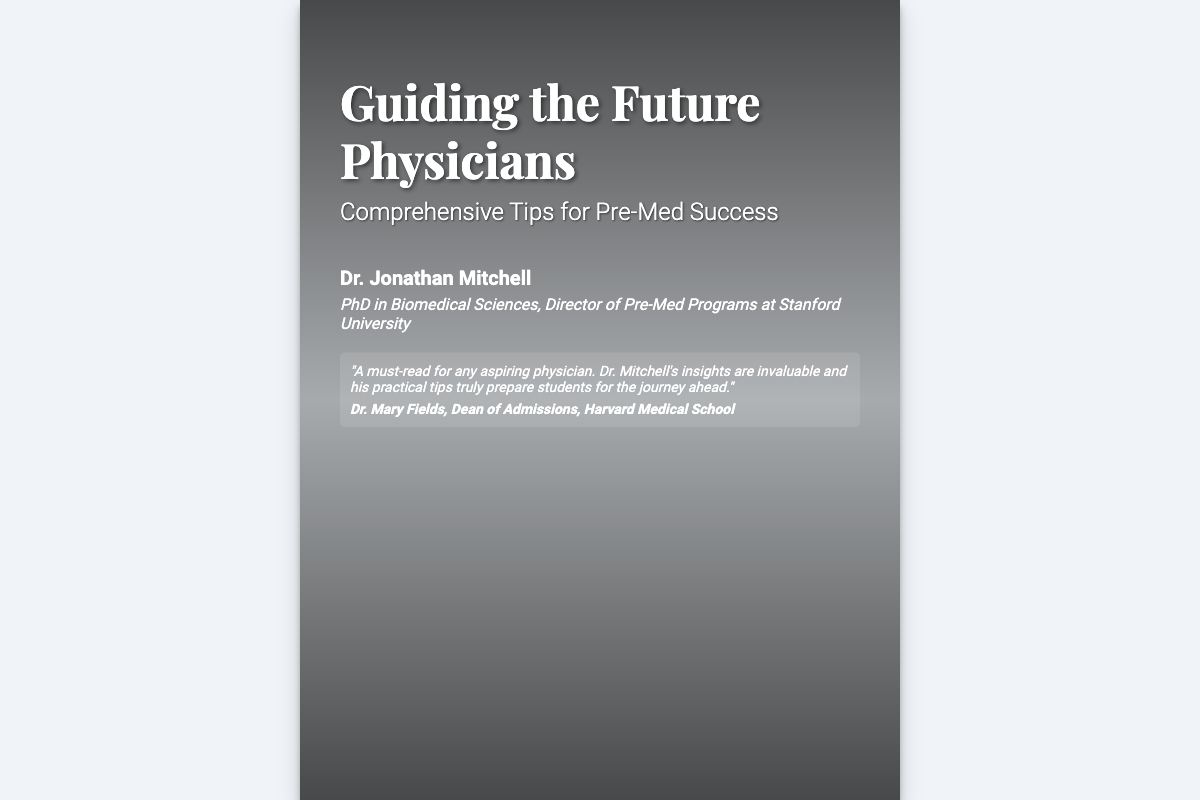What is the title of the book? The title is prominently displayed at the top of the book cover.
Answer: Guiding the Future Physicians Who is the author of the book? The author's name is listed below the title on the book cover.
Answer: Dr. Jonathan Mitchell What is Dr. Mitchell's credential? The credentials are stated below the author's name, indicating his qualifications.
Answer: PhD in Biomedical Sciences, Director of Pre-Med Programs at Stanford University What type of tips does the book provide? The subtitle indicates that the book offers essential guidance on a specific topic.
Answer: Comprehensive Tips for Pre-Med Success Who endorsed the book? The endorsement section includes the name of the reviewer providing accolades for the book.
Answer: Dr. Mary Fields What is Dr. Fields' position? The endorsement includes Dr. Fields' title, affirming her professional status.
Answer: Dean of Admissions, Harvard Medical School What color is the background of the book cover? The book cover’s background color and style are described visually in the rendering.
Answer: #f0f4f8 What does the stethoscope symbolize in the design? The stethoscope is a common symbol associated with the medical profession, representing healthcare.
Answer: Healthcare What is the visual element that emphasizes success besides the stethoscope? The design features an element that often represents victory and achievement.
Answer: Laurel wreath 